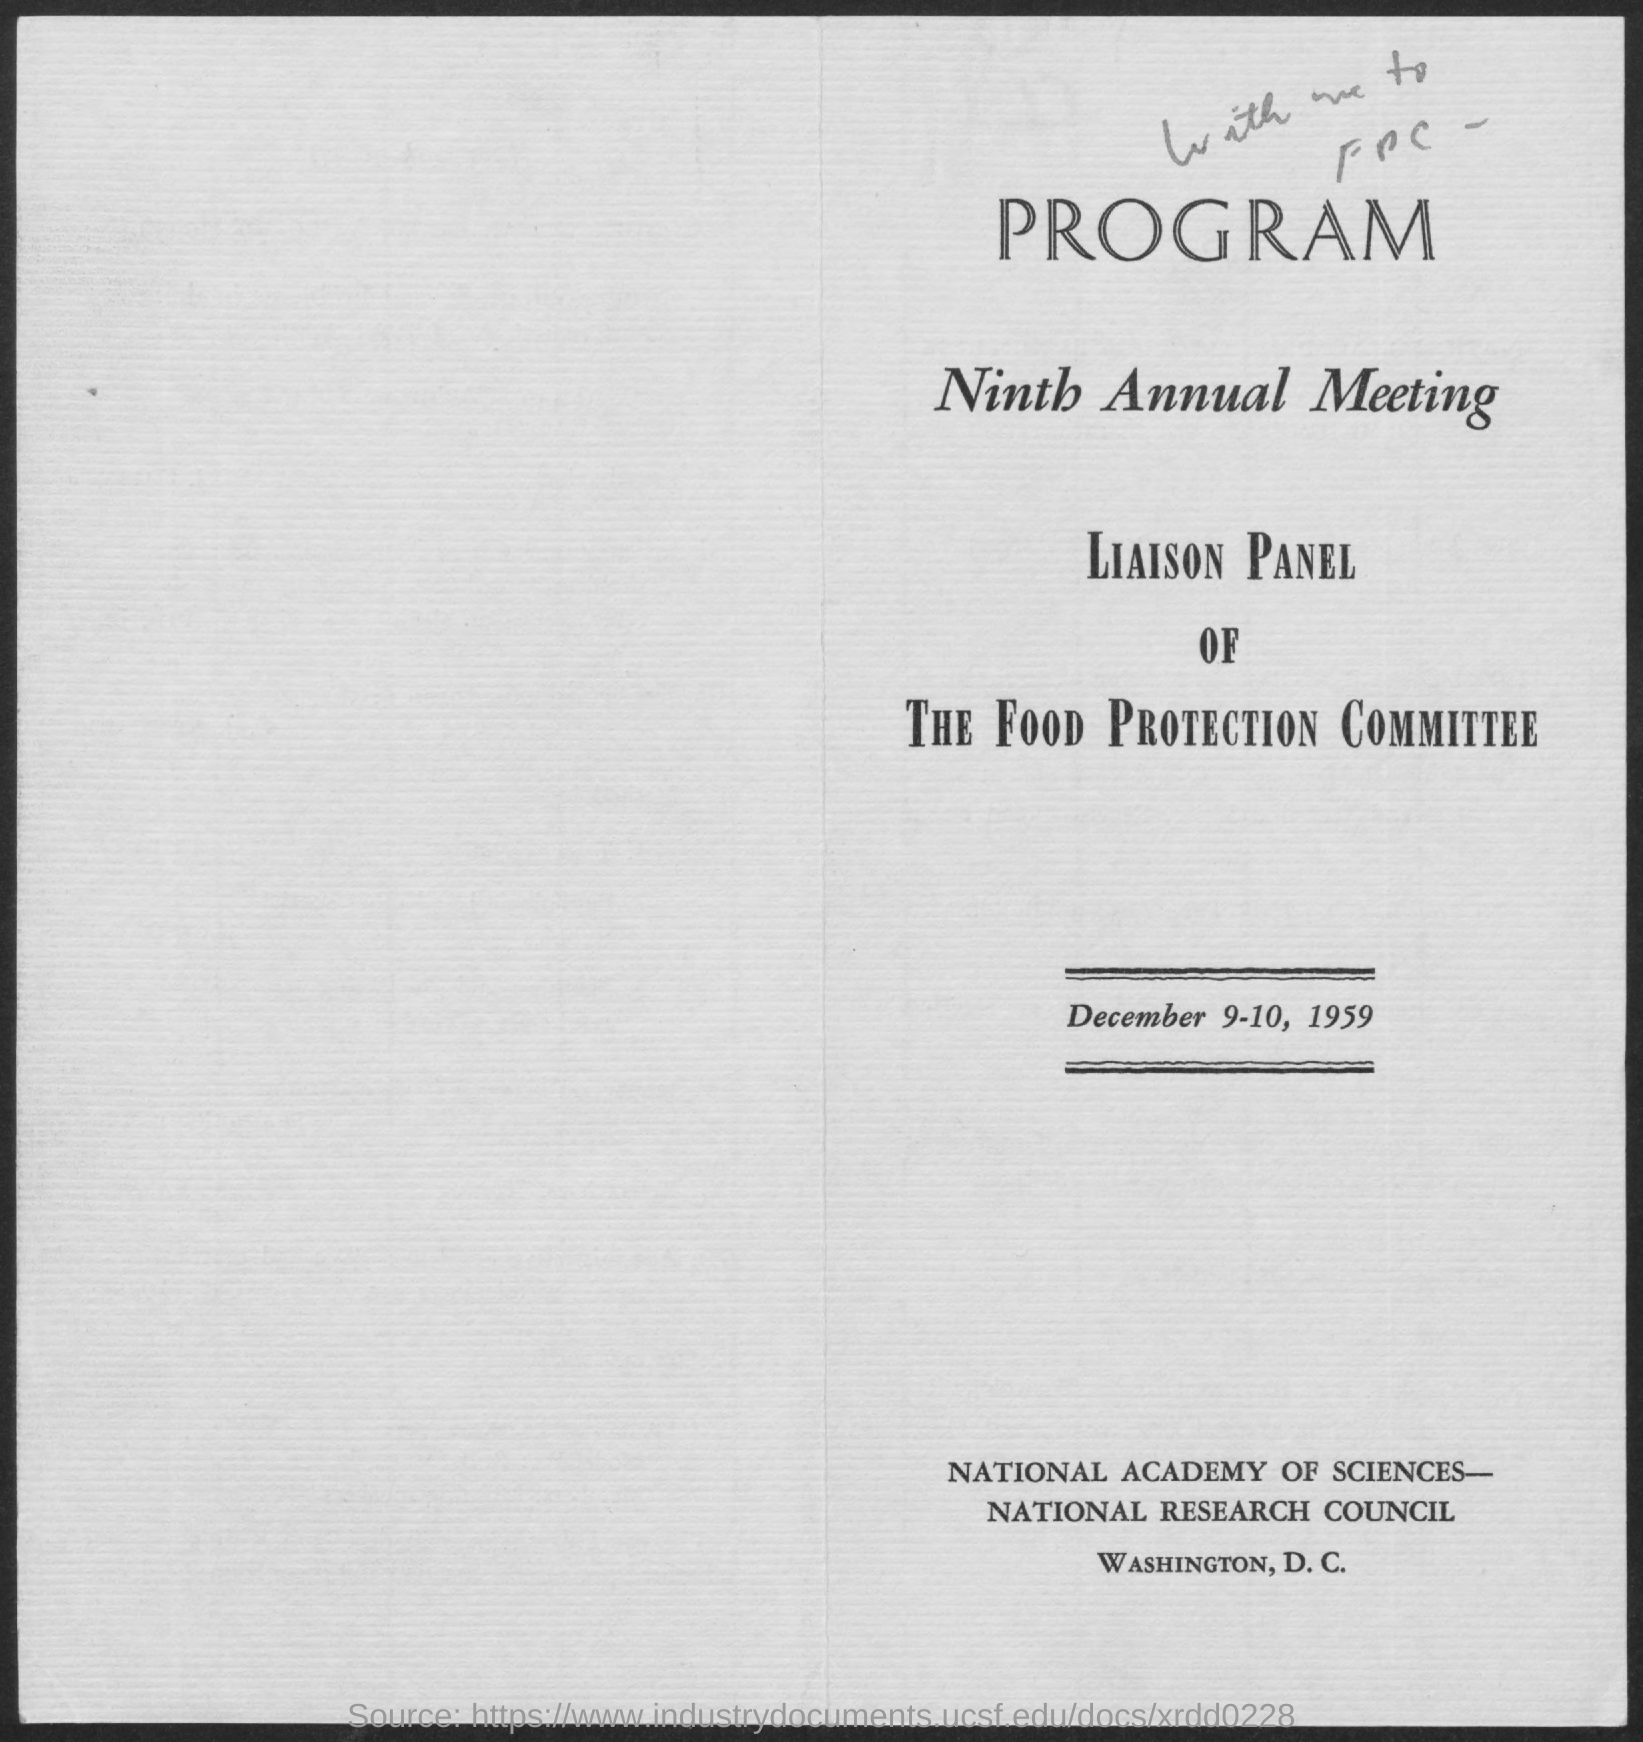When was the ninth annual meeting on liason panel of the food protection committee held?
Make the answer very short. December 9-10, 1959. 